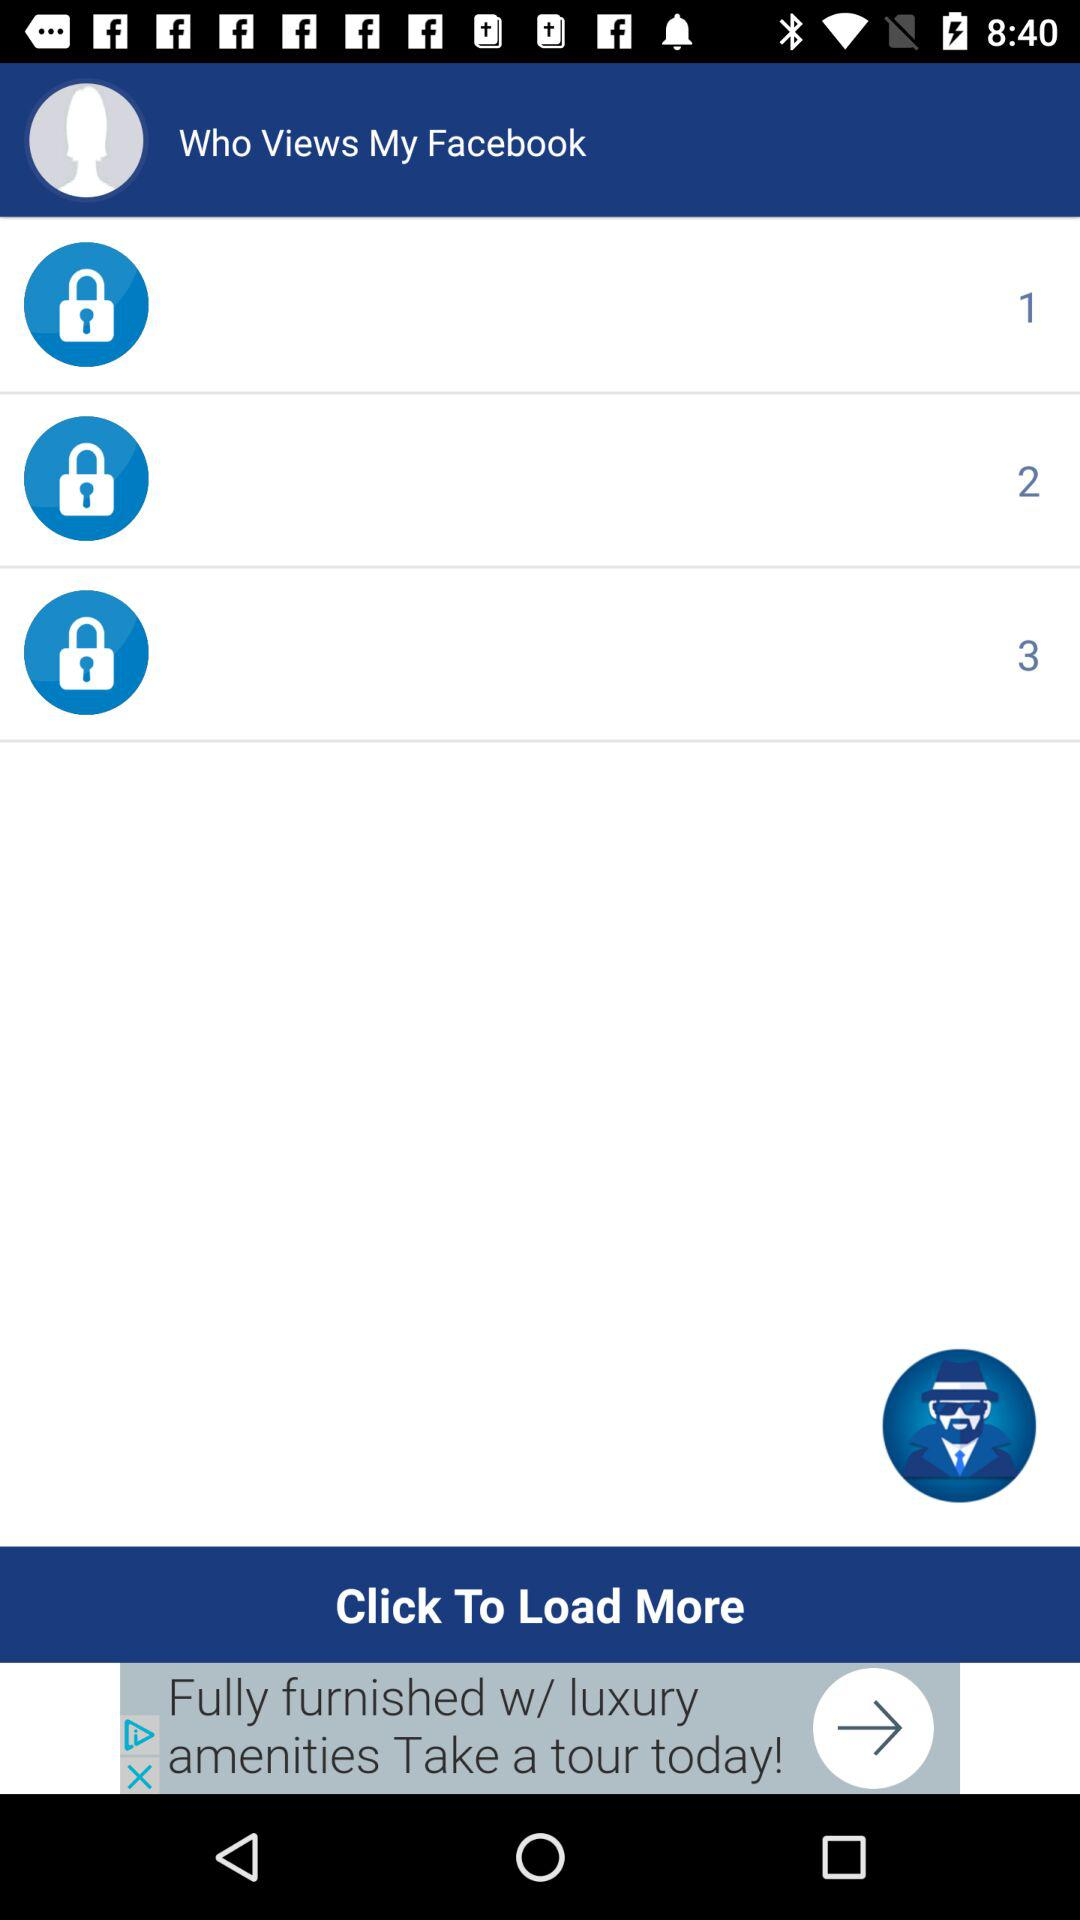What is the application name? The application name is "Who Views My Facebook". 